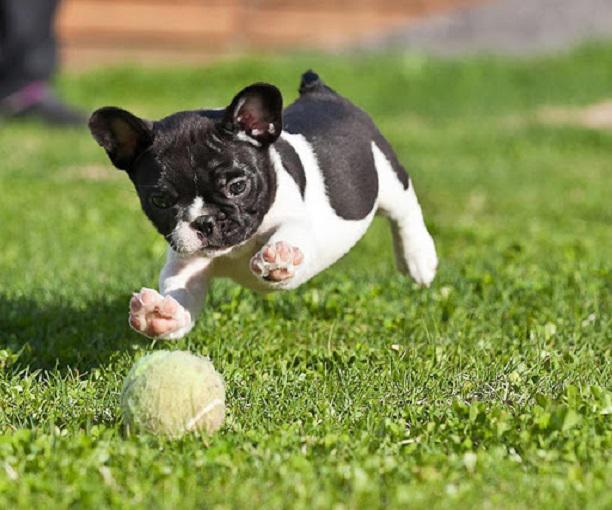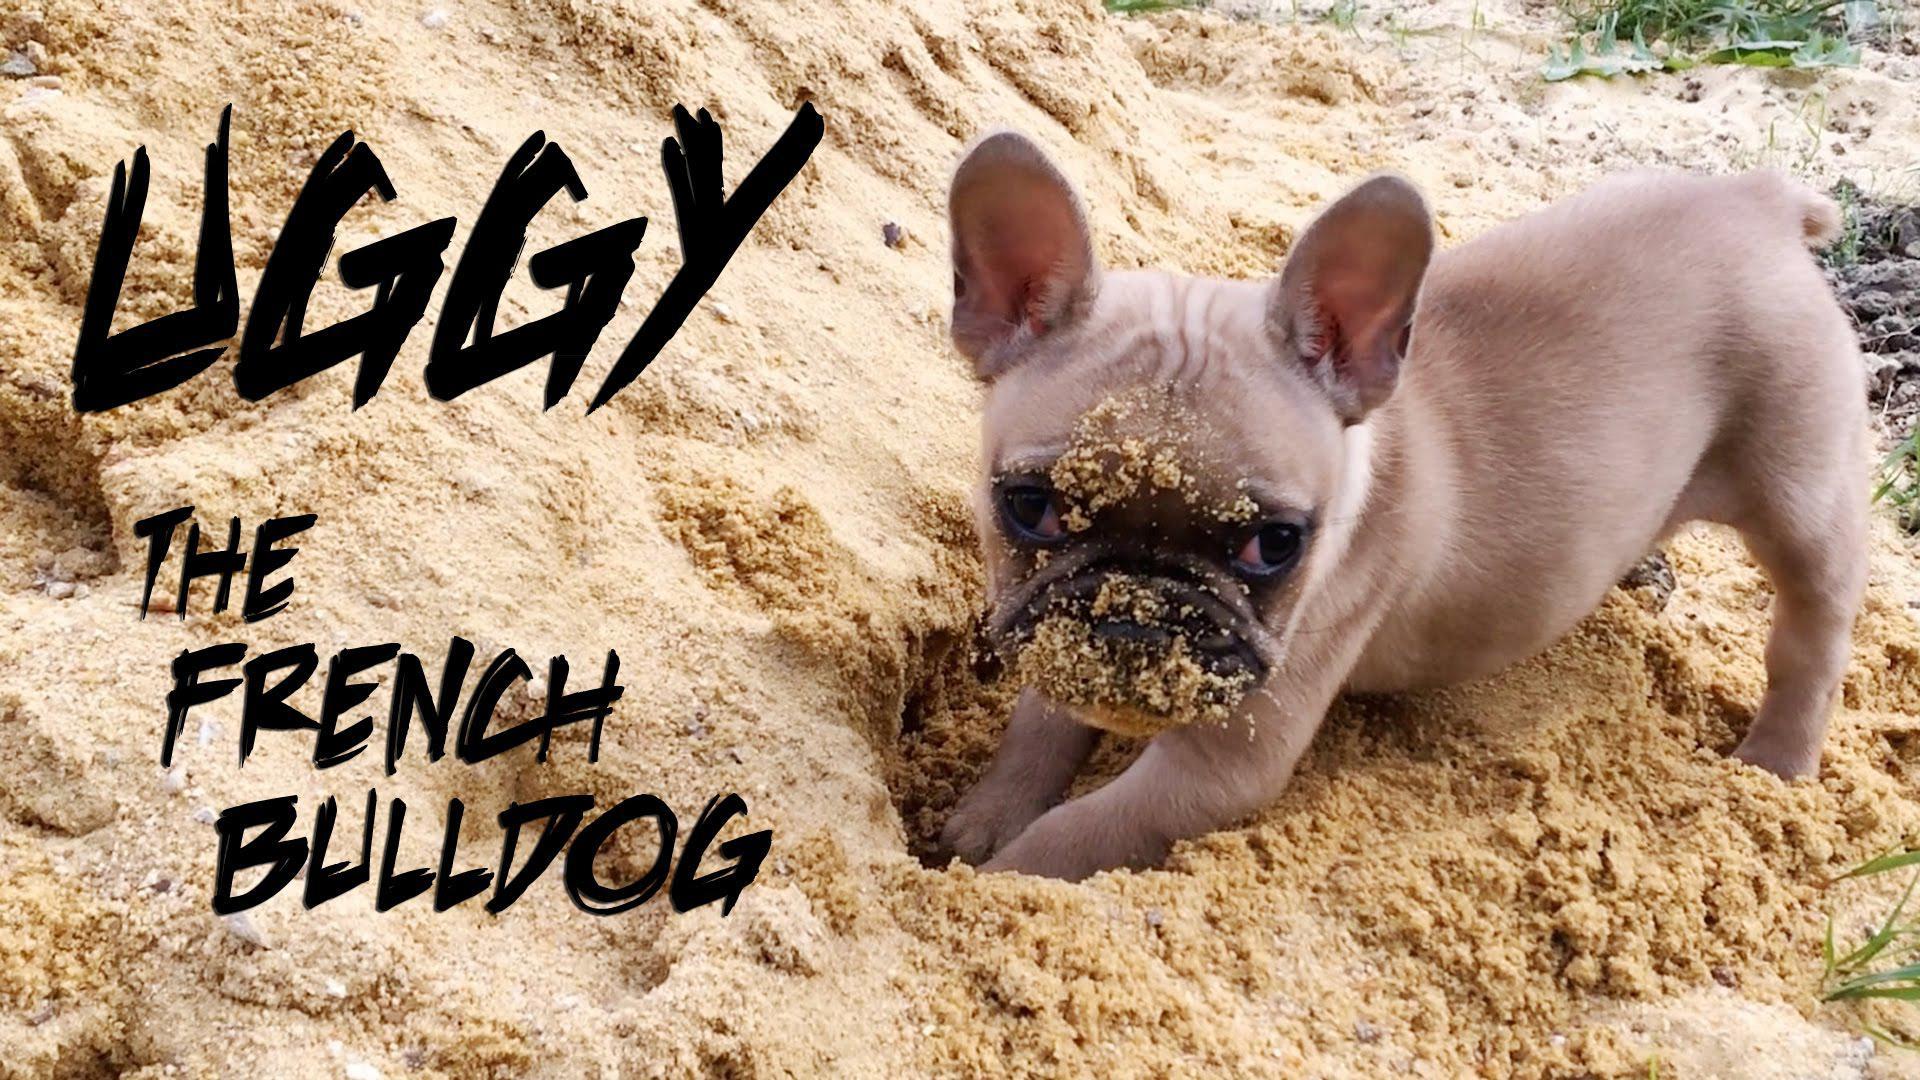The first image is the image on the left, the second image is the image on the right. Evaluate the accuracy of this statement regarding the images: "An image shows a tennis ball in front of one french bulldog, but not in contact with it.". Is it true? Answer yes or no. Yes. The first image is the image on the left, the second image is the image on the right. Evaluate the accuracy of this statement regarding the images: "The left image includes a dog playing with a tennis ball.". Is it true? Answer yes or no. Yes. 